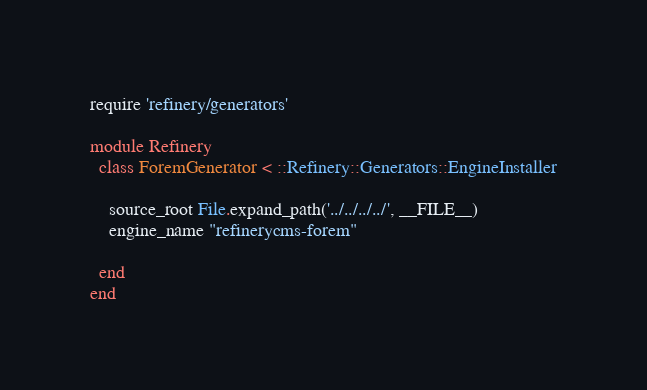<code> <loc_0><loc_0><loc_500><loc_500><_Ruby_>require 'refinery/generators'

module Refinery
  class ForemGenerator < ::Refinery::Generators::EngineInstaller

    source_root File.expand_path('../../../../', __FILE__)
    engine_name "refinerycms-forem"

  end
end</code> 